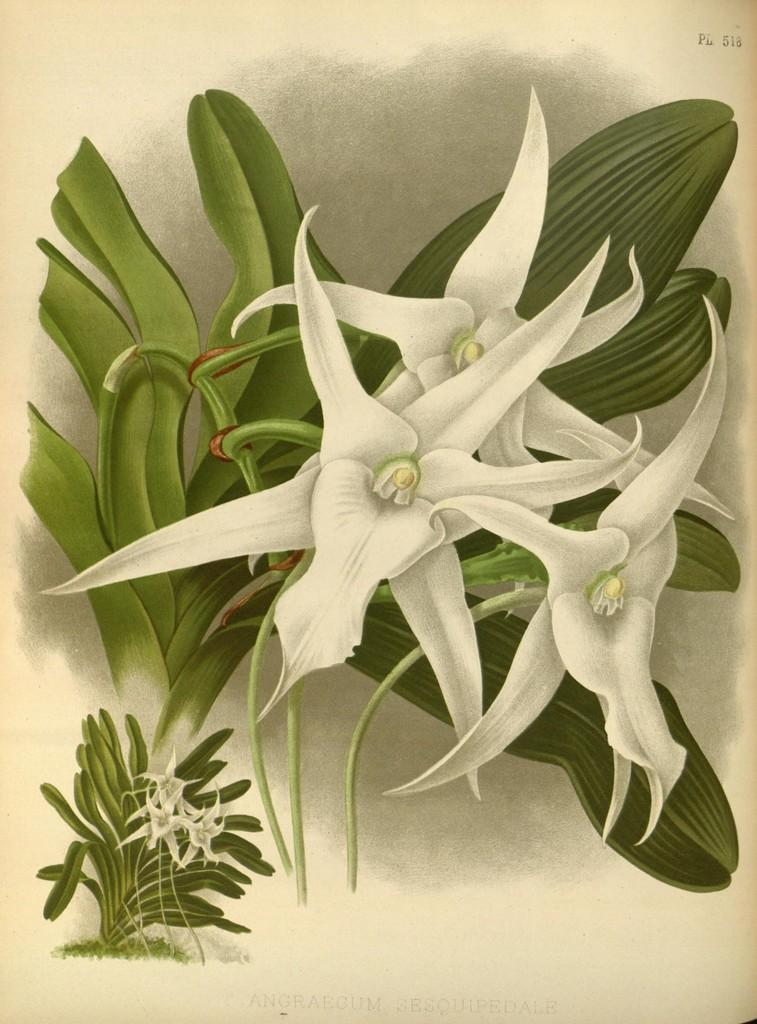What type of art is featured in the image? The image contains an art piece. What is the subject matter of the art piece? The art piece depicts flowers and leaves. What type of jelly can be seen dripping from the flowers in the art piece? There is no jelly present in the art piece; it depicts flowers and leaves without any additional elements. 